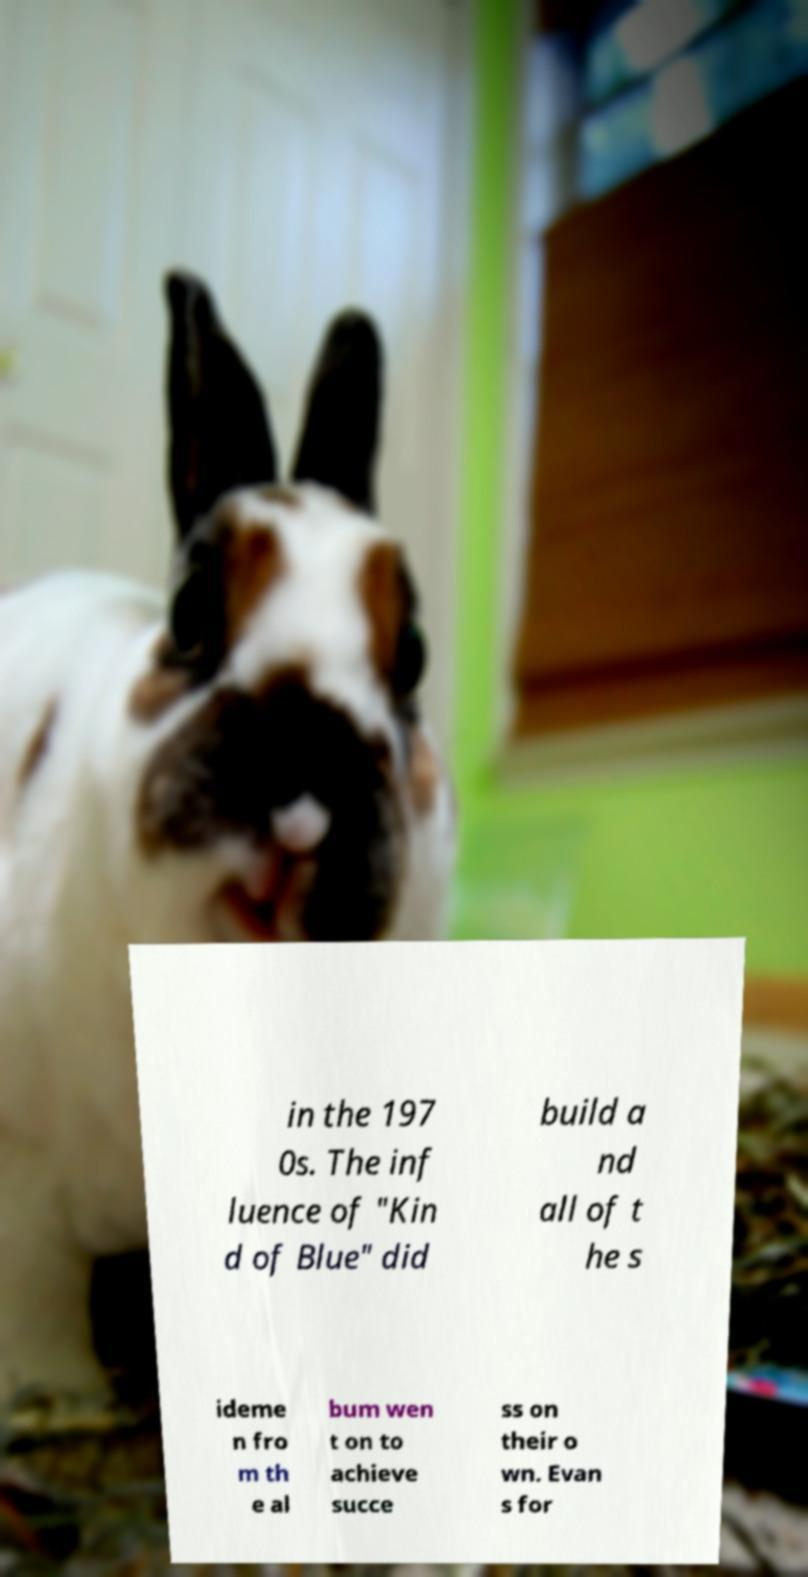For documentation purposes, I need the text within this image transcribed. Could you provide that? in the 197 0s. The inf luence of "Kin d of Blue" did build a nd all of t he s ideme n fro m th e al bum wen t on to achieve succe ss on their o wn. Evan s for 